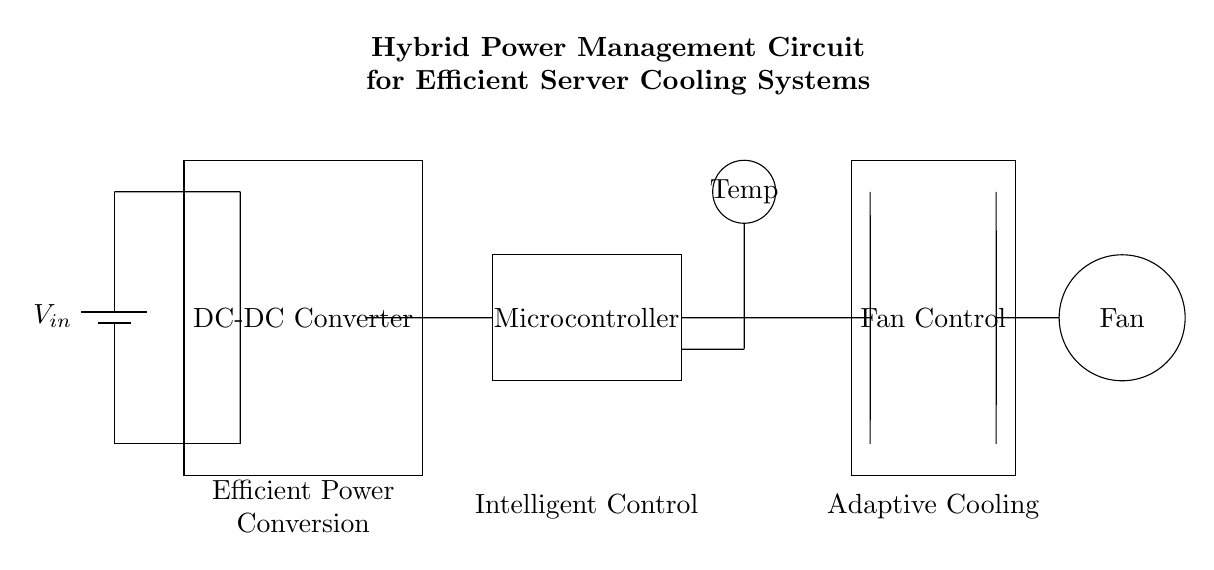What is the main power source in this circuit? The main power source in the circuit is labeled as V in, which is represented by the battery symbol. This indicates that the circuit is powered from a battery.
Answer: V in What component is responsible for controlling the fan? The Fan Control section of the circuit, depicted by the rectangular shape and labeled clearly, indicates that this component is responsible for controlling the fan's operation based on the system requirements.
Answer: Fan Control How many main components are there in this circuit? To determine the number of main components, we can count the distinct labeled blocks: DC-DC Converter, Microcontroller, Temperature Sensor, and Fan Control. This totals to four main components.
Answer: Four What type of control is implemented in this circuit? The circuit implements Intelligent Control as indicated by the label associated with the Microcontroller component, suggesting that it manages operations based on data from other components.
Answer: Intelligent Control What is the purpose of the Temperature Sensor in this circuit? The Temperature Sensor is used to monitor temperature, providing data that is likely used to regulate the fan speed and enhance energy efficiency in server cooling operations.
Answer: Monitor temperature Which component converts the input voltage? The DC-DC Converter is responsible for converting the input voltage to a suitable level, facilitating power management for other components in the circuit.
Answer: DC-DC Converter What feature is indicated by the Adaptive Cooling label? The Adaptive Cooling label associated with the Fan Control component suggests that the system adjusts fan operation based on temperature readings to optimize cooling efficiency.
Answer: Adjust fan operation 